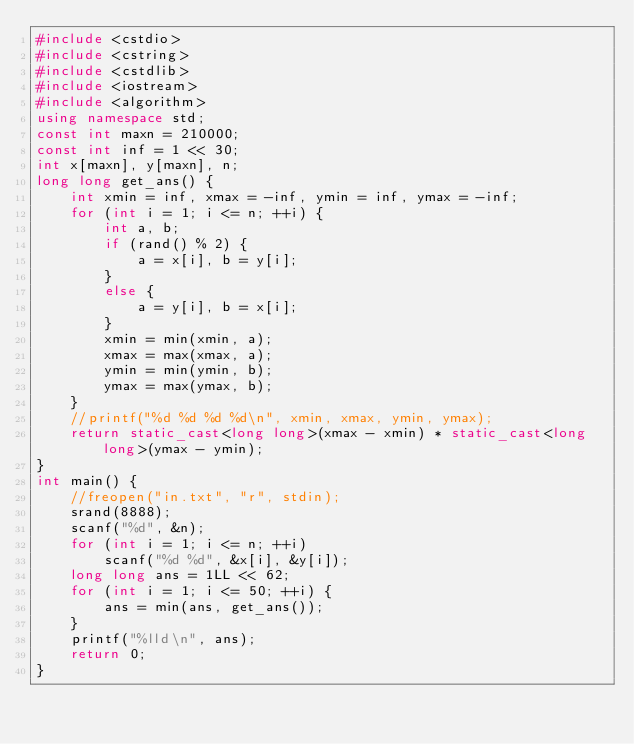<code> <loc_0><loc_0><loc_500><loc_500><_C++_>#include <cstdio>
#include <cstring>
#include <cstdlib>
#include <iostream>
#include <algorithm>
using namespace std;
const int maxn = 210000;
const int inf = 1 << 30;
int x[maxn], y[maxn], n;
long long get_ans() {
	int xmin = inf, xmax = -inf, ymin = inf, ymax = -inf;
	for (int i = 1; i <= n; ++i) {
		int a, b;
		if (rand() % 2) {
			a = x[i], b = y[i];
		}
		else {
			a = y[i], b = x[i];
		}
		xmin = min(xmin, a);
		xmax = max(xmax, a);
		ymin = min(ymin, b);
		ymax = max(ymax, b);
	}
	//printf("%d %d %d %d\n", xmin, xmax, ymin, ymax);
	return static_cast<long long>(xmax - xmin) * static_cast<long long>(ymax - ymin);
}
int main() {
	//freopen("in.txt", "r", stdin);
	srand(8888);
	scanf("%d", &n);
	for (int i = 1; i <= n; ++i)
		scanf("%d %d", &x[i], &y[i]);
	long long ans = 1LL << 62;
	for (int i = 1; i <= 50; ++i) {
		ans = min(ans, get_ans());
	}
	printf("%lld\n", ans);
	return 0;
}</code> 